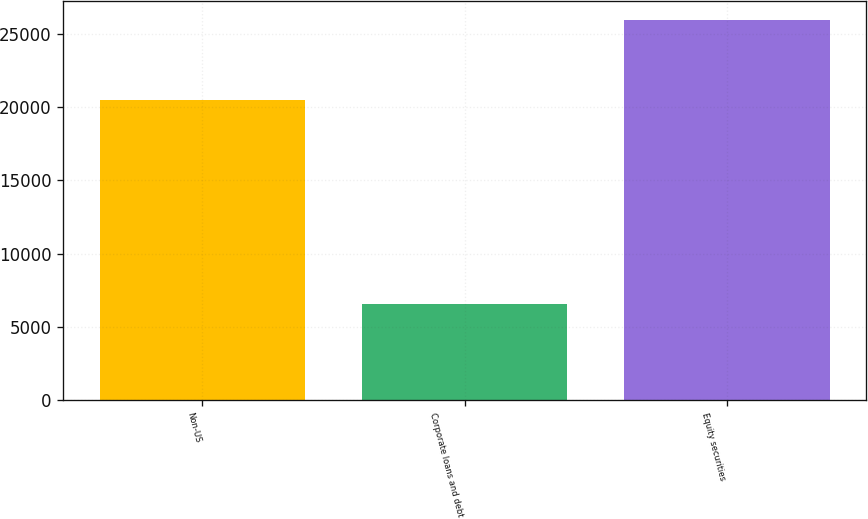<chart> <loc_0><loc_0><loc_500><loc_500><bar_chart><fcel>Non-US<fcel>Corporate loans and debt<fcel>Equity securities<nl><fcel>20502<fcel>6570<fcel>25941<nl></chart> 